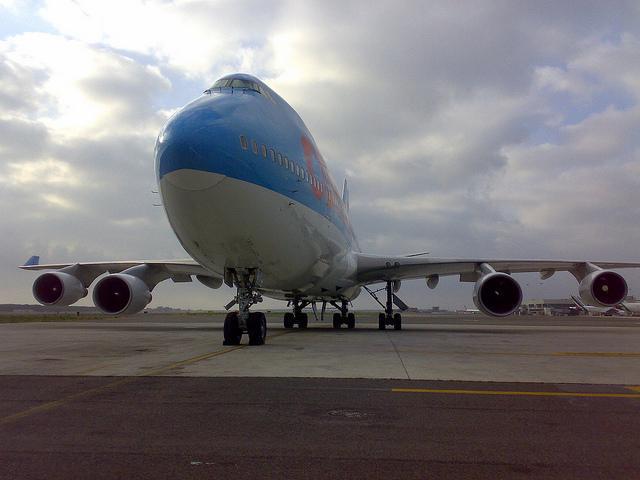How many engines are shown?
Give a very brief answer. 4. How many toilet bowl brushes are in this picture?
Give a very brief answer. 0. 